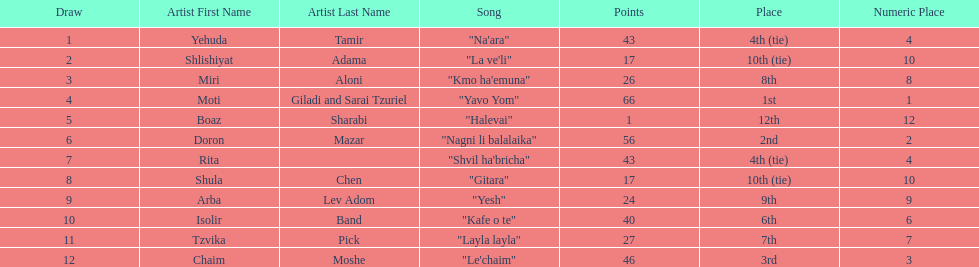What are the number of times an artist earned first place? 1. 